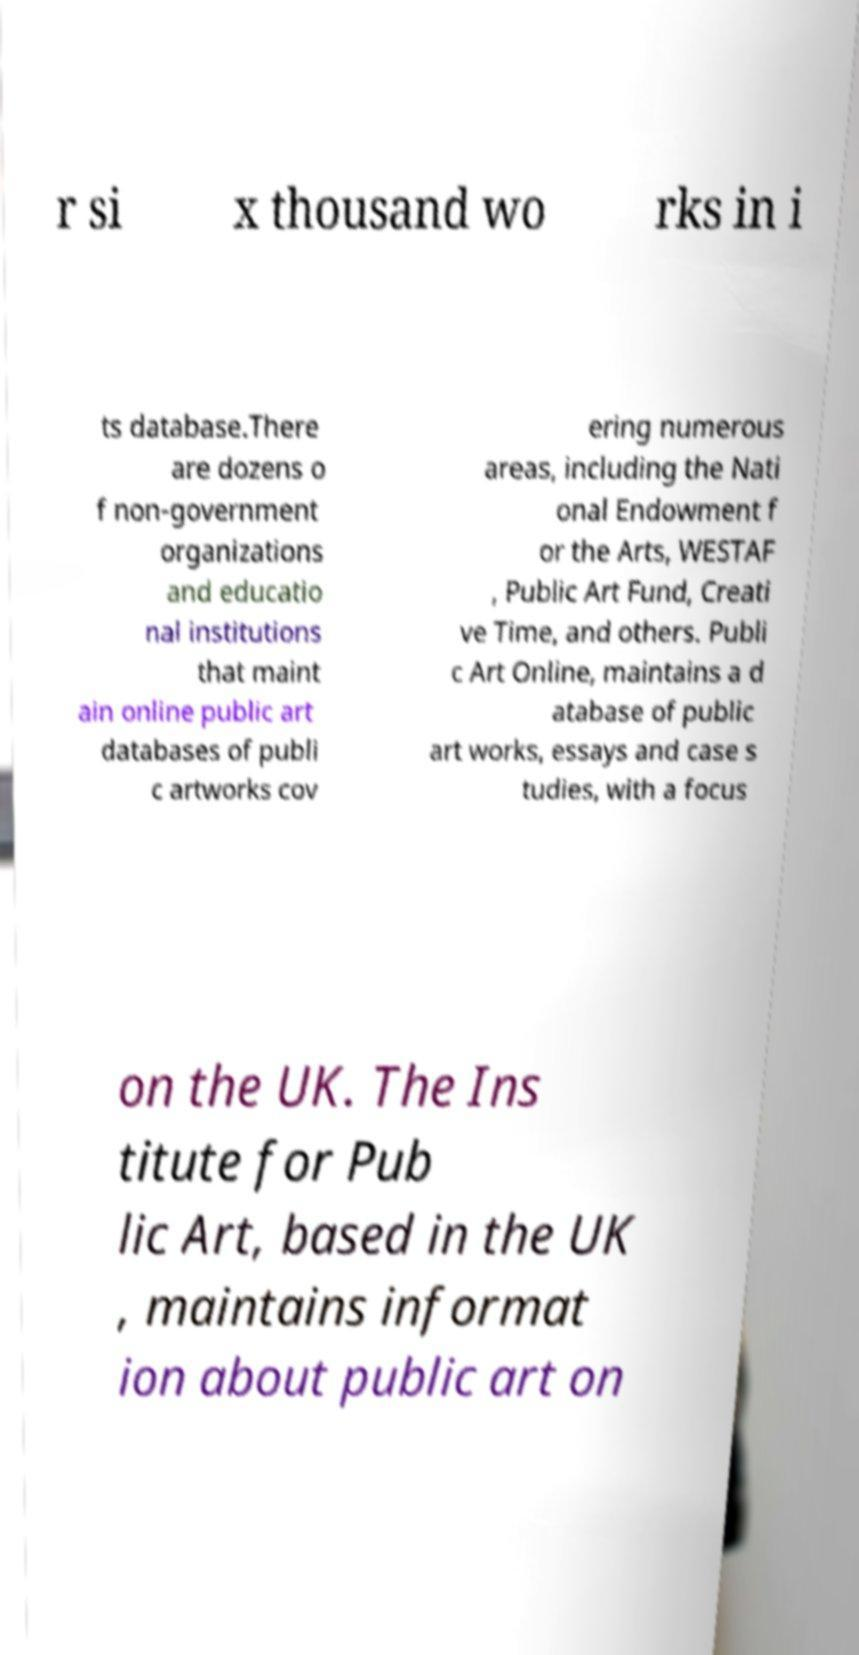What messages or text are displayed in this image? I need them in a readable, typed format. r si x thousand wo rks in i ts database.There are dozens o f non-government organizations and educatio nal institutions that maint ain online public art databases of publi c artworks cov ering numerous areas, including the Nati onal Endowment f or the Arts, WESTAF , Public Art Fund, Creati ve Time, and others. Publi c Art Online, maintains a d atabase of public art works, essays and case s tudies, with a focus on the UK. The Ins titute for Pub lic Art, based in the UK , maintains informat ion about public art on 